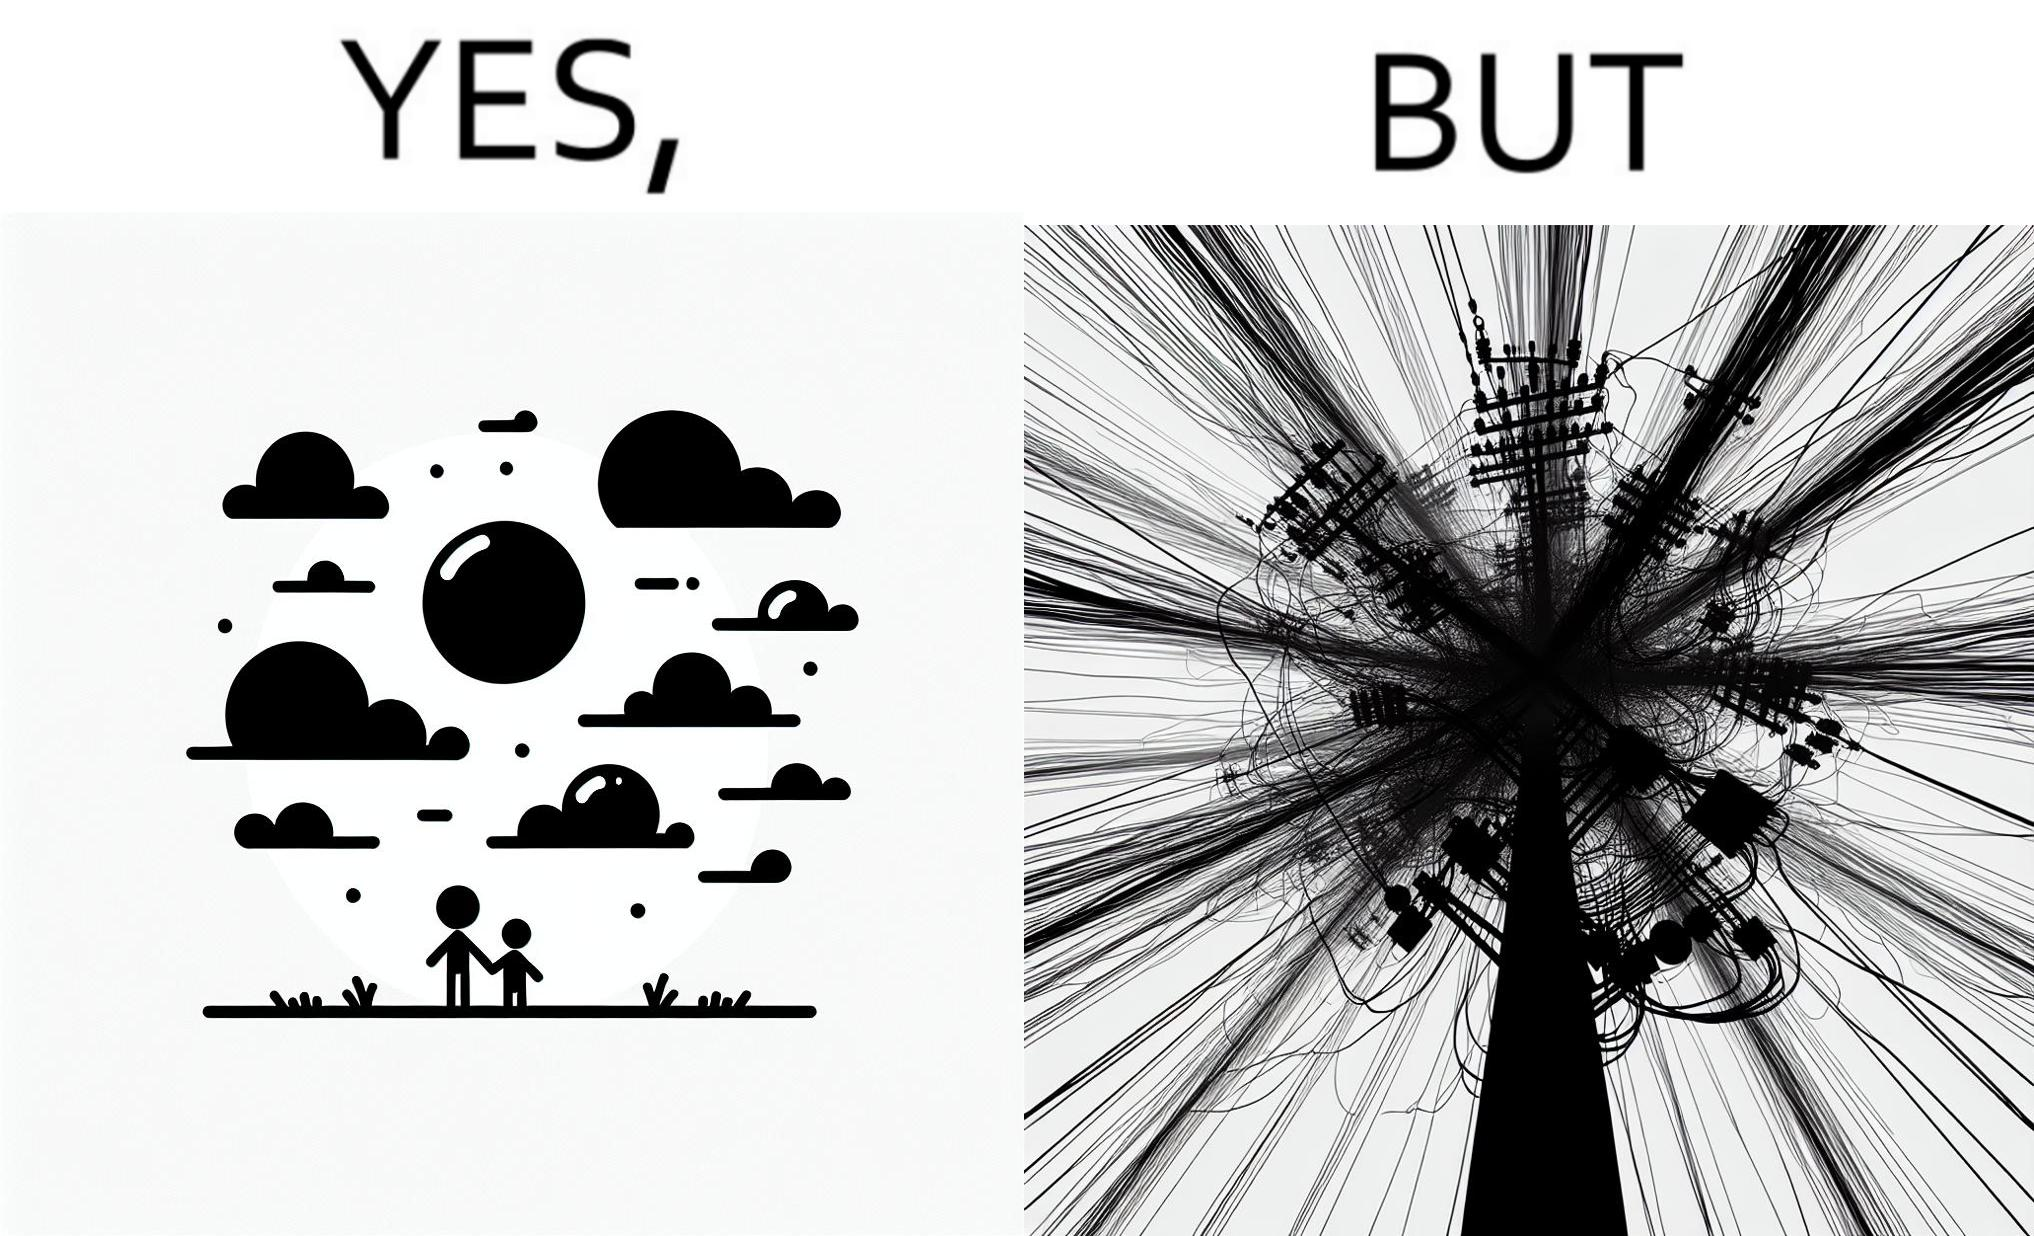Does this image contain satire or humor? Yes, this image is satirical. 